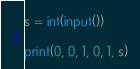Convert code to text. <code><loc_0><loc_0><loc_500><loc_500><_Python_>s = int(input())

print(0, 0, 1, 0, 1, s)</code> 